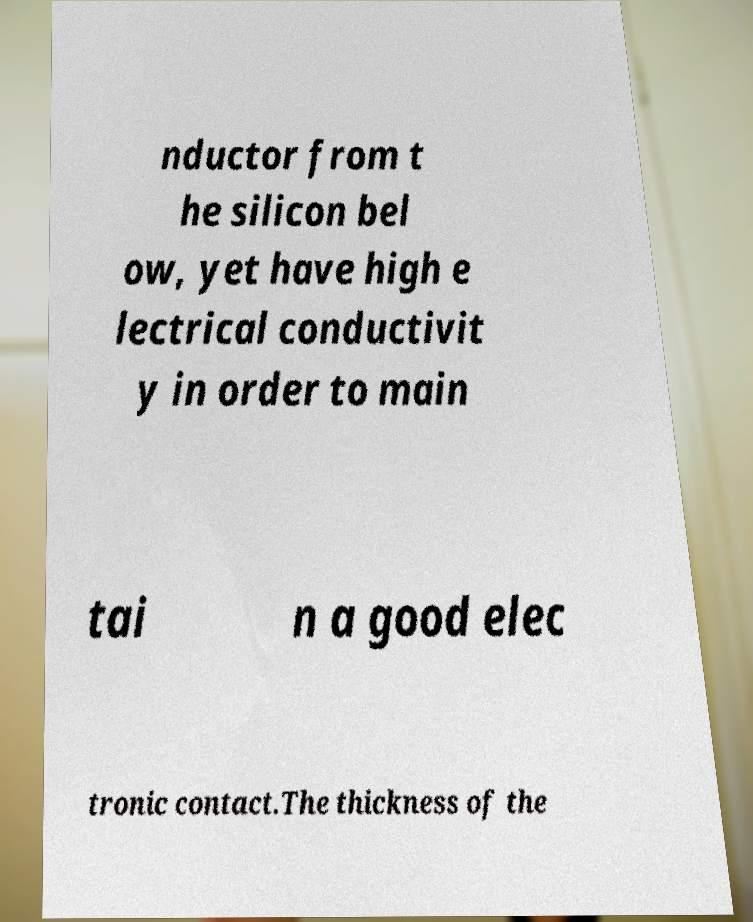Could you extract and type out the text from this image? nductor from t he silicon bel ow, yet have high e lectrical conductivit y in order to main tai n a good elec tronic contact.The thickness of the 